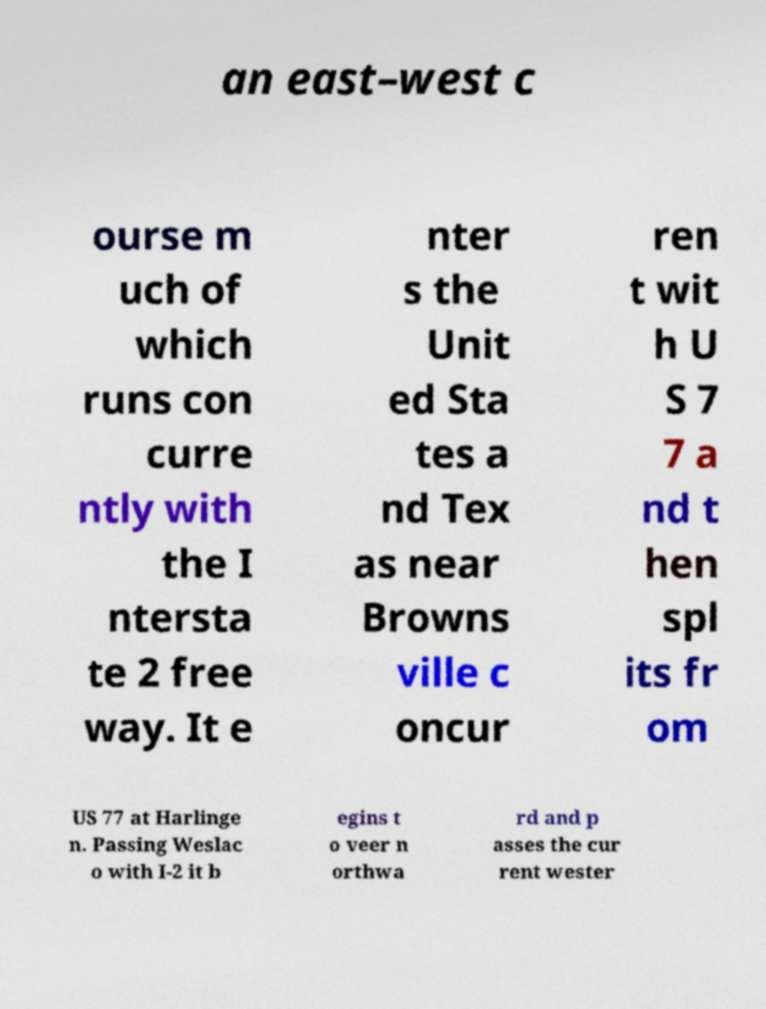For documentation purposes, I need the text within this image transcribed. Could you provide that? an east–west c ourse m uch of which runs con curre ntly with the I ntersta te 2 free way. It e nter s the Unit ed Sta tes a nd Tex as near Browns ville c oncur ren t wit h U S 7 7 a nd t hen spl its fr om US 77 at Harlinge n. Passing Weslac o with I-2 it b egins t o veer n orthwa rd and p asses the cur rent wester 